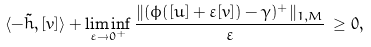Convert formula to latex. <formula><loc_0><loc_0><loc_500><loc_500>\langle - \tilde { h } , [ v ] \rangle + \liminf _ { \varepsilon \to 0 ^ { + } } \frac { \| ( \phi ( [ u ] + \varepsilon [ v ] ) - \gamma ) ^ { + } \| _ { 1 , M } } { \varepsilon } \, \geq 0 ,</formula> 